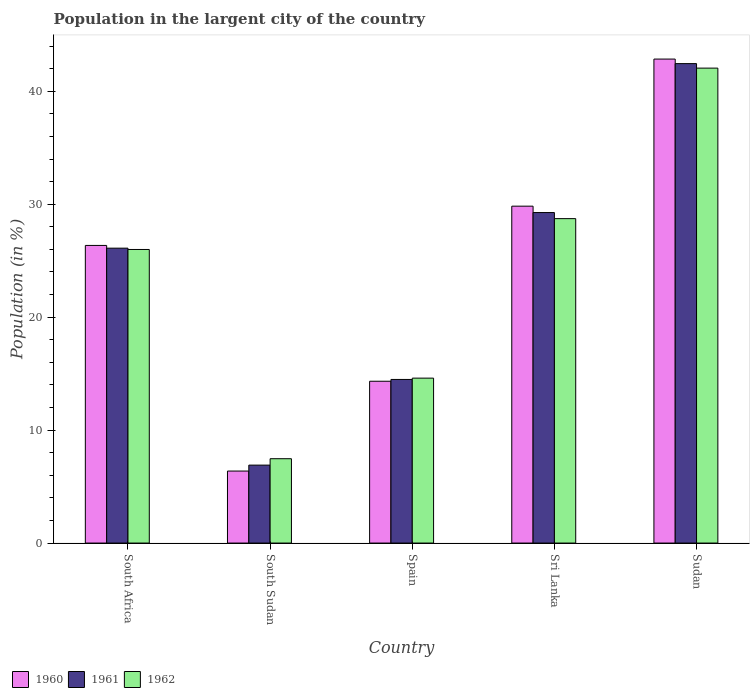How many groups of bars are there?
Give a very brief answer. 5. Are the number of bars per tick equal to the number of legend labels?
Provide a succinct answer. Yes. How many bars are there on the 1st tick from the left?
Your response must be concise. 3. What is the label of the 4th group of bars from the left?
Provide a short and direct response. Sri Lanka. In how many cases, is the number of bars for a given country not equal to the number of legend labels?
Give a very brief answer. 0. What is the percentage of population in the largent city in 1961 in Sri Lanka?
Your answer should be compact. 29.26. Across all countries, what is the maximum percentage of population in the largent city in 1962?
Offer a very short reply. 42.05. Across all countries, what is the minimum percentage of population in the largent city in 1962?
Keep it short and to the point. 7.47. In which country was the percentage of population in the largent city in 1960 maximum?
Give a very brief answer. Sudan. In which country was the percentage of population in the largent city in 1961 minimum?
Give a very brief answer. South Sudan. What is the total percentage of population in the largent city in 1960 in the graph?
Provide a succinct answer. 119.72. What is the difference between the percentage of population in the largent city in 1962 in South Sudan and that in Sri Lanka?
Your answer should be compact. -21.25. What is the difference between the percentage of population in the largent city in 1962 in Sri Lanka and the percentage of population in the largent city in 1960 in Spain?
Your answer should be compact. 14.39. What is the average percentage of population in the largent city in 1960 per country?
Your answer should be compact. 23.94. What is the difference between the percentage of population in the largent city of/in 1961 and percentage of population in the largent city of/in 1960 in South Africa?
Keep it short and to the point. -0.24. What is the ratio of the percentage of population in the largent city in 1960 in Spain to that in Sudan?
Make the answer very short. 0.33. What is the difference between the highest and the second highest percentage of population in the largent city in 1962?
Keep it short and to the point. -16.06. What is the difference between the highest and the lowest percentage of population in the largent city in 1961?
Make the answer very short. 35.55. In how many countries, is the percentage of population in the largent city in 1960 greater than the average percentage of population in the largent city in 1960 taken over all countries?
Your response must be concise. 3. Is the sum of the percentage of population in the largent city in 1960 in South Sudan and Sudan greater than the maximum percentage of population in the largent city in 1962 across all countries?
Offer a very short reply. Yes. Is it the case that in every country, the sum of the percentage of population in the largent city in 1960 and percentage of population in the largent city in 1962 is greater than the percentage of population in the largent city in 1961?
Ensure brevity in your answer.  Yes. What is the difference between two consecutive major ticks on the Y-axis?
Offer a terse response. 10. Does the graph contain any zero values?
Offer a very short reply. No. Where does the legend appear in the graph?
Keep it short and to the point. Bottom left. How many legend labels are there?
Provide a succinct answer. 3. How are the legend labels stacked?
Make the answer very short. Horizontal. What is the title of the graph?
Provide a succinct answer. Population in the largent city of the country. What is the label or title of the X-axis?
Your response must be concise. Country. What is the label or title of the Y-axis?
Offer a terse response. Population (in %). What is the Population (in %) in 1960 in South Africa?
Your answer should be very brief. 26.35. What is the Population (in %) of 1961 in South Africa?
Your answer should be very brief. 26.11. What is the Population (in %) of 1962 in South Africa?
Your answer should be very brief. 25.99. What is the Population (in %) of 1960 in South Sudan?
Your answer should be very brief. 6.37. What is the Population (in %) in 1961 in South Sudan?
Make the answer very short. 6.9. What is the Population (in %) in 1962 in South Sudan?
Your answer should be very brief. 7.47. What is the Population (in %) in 1960 in Spain?
Make the answer very short. 14.33. What is the Population (in %) of 1961 in Spain?
Offer a very short reply. 14.48. What is the Population (in %) in 1962 in Spain?
Offer a terse response. 14.6. What is the Population (in %) in 1960 in Sri Lanka?
Offer a terse response. 29.82. What is the Population (in %) of 1961 in Sri Lanka?
Make the answer very short. 29.26. What is the Population (in %) of 1962 in Sri Lanka?
Offer a terse response. 28.72. What is the Population (in %) in 1960 in Sudan?
Make the answer very short. 42.85. What is the Population (in %) in 1961 in Sudan?
Give a very brief answer. 42.45. What is the Population (in %) of 1962 in Sudan?
Your answer should be very brief. 42.05. Across all countries, what is the maximum Population (in %) of 1960?
Make the answer very short. 42.85. Across all countries, what is the maximum Population (in %) in 1961?
Provide a succinct answer. 42.45. Across all countries, what is the maximum Population (in %) in 1962?
Provide a succinct answer. 42.05. Across all countries, what is the minimum Population (in %) in 1960?
Your response must be concise. 6.37. Across all countries, what is the minimum Population (in %) in 1961?
Make the answer very short. 6.9. Across all countries, what is the minimum Population (in %) of 1962?
Your answer should be very brief. 7.47. What is the total Population (in %) of 1960 in the graph?
Your answer should be compact. 119.72. What is the total Population (in %) in 1961 in the graph?
Your answer should be compact. 119.19. What is the total Population (in %) of 1962 in the graph?
Your response must be concise. 118.82. What is the difference between the Population (in %) of 1960 in South Africa and that in South Sudan?
Provide a succinct answer. 19.97. What is the difference between the Population (in %) of 1961 in South Africa and that in South Sudan?
Your answer should be compact. 19.21. What is the difference between the Population (in %) in 1962 in South Africa and that in South Sudan?
Provide a succinct answer. 18.52. What is the difference between the Population (in %) in 1960 in South Africa and that in Spain?
Provide a succinct answer. 12.02. What is the difference between the Population (in %) of 1961 in South Africa and that in Spain?
Offer a very short reply. 11.62. What is the difference between the Population (in %) in 1962 in South Africa and that in Spain?
Provide a succinct answer. 11.39. What is the difference between the Population (in %) in 1960 in South Africa and that in Sri Lanka?
Ensure brevity in your answer.  -3.48. What is the difference between the Population (in %) of 1961 in South Africa and that in Sri Lanka?
Ensure brevity in your answer.  -3.15. What is the difference between the Population (in %) in 1962 in South Africa and that in Sri Lanka?
Your response must be concise. -2.73. What is the difference between the Population (in %) of 1960 in South Africa and that in Sudan?
Your answer should be compact. -16.5. What is the difference between the Population (in %) of 1961 in South Africa and that in Sudan?
Keep it short and to the point. -16.34. What is the difference between the Population (in %) in 1962 in South Africa and that in Sudan?
Your response must be concise. -16.06. What is the difference between the Population (in %) in 1960 in South Sudan and that in Spain?
Give a very brief answer. -7.95. What is the difference between the Population (in %) of 1961 in South Sudan and that in Spain?
Give a very brief answer. -7.58. What is the difference between the Population (in %) of 1962 in South Sudan and that in Spain?
Keep it short and to the point. -7.13. What is the difference between the Population (in %) in 1960 in South Sudan and that in Sri Lanka?
Offer a terse response. -23.45. What is the difference between the Population (in %) in 1961 in South Sudan and that in Sri Lanka?
Provide a short and direct response. -22.36. What is the difference between the Population (in %) in 1962 in South Sudan and that in Sri Lanka?
Keep it short and to the point. -21.25. What is the difference between the Population (in %) of 1960 in South Sudan and that in Sudan?
Your answer should be very brief. -36.47. What is the difference between the Population (in %) in 1961 in South Sudan and that in Sudan?
Ensure brevity in your answer.  -35.55. What is the difference between the Population (in %) in 1962 in South Sudan and that in Sudan?
Give a very brief answer. -34.58. What is the difference between the Population (in %) in 1960 in Spain and that in Sri Lanka?
Offer a terse response. -15.5. What is the difference between the Population (in %) of 1961 in Spain and that in Sri Lanka?
Make the answer very short. -14.78. What is the difference between the Population (in %) in 1962 in Spain and that in Sri Lanka?
Offer a terse response. -14.12. What is the difference between the Population (in %) of 1960 in Spain and that in Sudan?
Give a very brief answer. -28.52. What is the difference between the Population (in %) of 1961 in Spain and that in Sudan?
Offer a terse response. -27.96. What is the difference between the Population (in %) in 1962 in Spain and that in Sudan?
Provide a short and direct response. -27.45. What is the difference between the Population (in %) of 1960 in Sri Lanka and that in Sudan?
Provide a succinct answer. -13.02. What is the difference between the Population (in %) of 1961 in Sri Lanka and that in Sudan?
Make the answer very short. -13.19. What is the difference between the Population (in %) in 1962 in Sri Lanka and that in Sudan?
Make the answer very short. -13.33. What is the difference between the Population (in %) of 1960 in South Africa and the Population (in %) of 1961 in South Sudan?
Give a very brief answer. 19.45. What is the difference between the Population (in %) of 1960 in South Africa and the Population (in %) of 1962 in South Sudan?
Give a very brief answer. 18.88. What is the difference between the Population (in %) in 1961 in South Africa and the Population (in %) in 1962 in South Sudan?
Provide a short and direct response. 18.64. What is the difference between the Population (in %) in 1960 in South Africa and the Population (in %) in 1961 in Spain?
Your answer should be compact. 11.86. What is the difference between the Population (in %) in 1960 in South Africa and the Population (in %) in 1962 in Spain?
Give a very brief answer. 11.75. What is the difference between the Population (in %) of 1961 in South Africa and the Population (in %) of 1962 in Spain?
Offer a terse response. 11.51. What is the difference between the Population (in %) of 1960 in South Africa and the Population (in %) of 1961 in Sri Lanka?
Give a very brief answer. -2.91. What is the difference between the Population (in %) of 1960 in South Africa and the Population (in %) of 1962 in Sri Lanka?
Offer a very short reply. -2.37. What is the difference between the Population (in %) in 1961 in South Africa and the Population (in %) in 1962 in Sri Lanka?
Offer a very short reply. -2.61. What is the difference between the Population (in %) in 1960 in South Africa and the Population (in %) in 1961 in Sudan?
Keep it short and to the point. -16.1. What is the difference between the Population (in %) in 1960 in South Africa and the Population (in %) in 1962 in Sudan?
Your answer should be compact. -15.7. What is the difference between the Population (in %) of 1961 in South Africa and the Population (in %) of 1962 in Sudan?
Offer a very short reply. -15.94. What is the difference between the Population (in %) in 1960 in South Sudan and the Population (in %) in 1961 in Spain?
Your answer should be compact. -8.11. What is the difference between the Population (in %) of 1960 in South Sudan and the Population (in %) of 1962 in Spain?
Ensure brevity in your answer.  -8.23. What is the difference between the Population (in %) in 1961 in South Sudan and the Population (in %) in 1962 in Spain?
Provide a succinct answer. -7.7. What is the difference between the Population (in %) of 1960 in South Sudan and the Population (in %) of 1961 in Sri Lanka?
Make the answer very short. -22.89. What is the difference between the Population (in %) of 1960 in South Sudan and the Population (in %) of 1962 in Sri Lanka?
Your response must be concise. -22.35. What is the difference between the Population (in %) in 1961 in South Sudan and the Population (in %) in 1962 in Sri Lanka?
Ensure brevity in your answer.  -21.82. What is the difference between the Population (in %) in 1960 in South Sudan and the Population (in %) in 1961 in Sudan?
Offer a very short reply. -36.07. What is the difference between the Population (in %) of 1960 in South Sudan and the Population (in %) of 1962 in Sudan?
Provide a short and direct response. -35.67. What is the difference between the Population (in %) in 1961 in South Sudan and the Population (in %) in 1962 in Sudan?
Give a very brief answer. -35.15. What is the difference between the Population (in %) of 1960 in Spain and the Population (in %) of 1961 in Sri Lanka?
Ensure brevity in your answer.  -14.93. What is the difference between the Population (in %) in 1960 in Spain and the Population (in %) in 1962 in Sri Lanka?
Offer a terse response. -14.39. What is the difference between the Population (in %) in 1961 in Spain and the Population (in %) in 1962 in Sri Lanka?
Offer a very short reply. -14.24. What is the difference between the Population (in %) of 1960 in Spain and the Population (in %) of 1961 in Sudan?
Make the answer very short. -28.12. What is the difference between the Population (in %) of 1960 in Spain and the Population (in %) of 1962 in Sudan?
Offer a very short reply. -27.72. What is the difference between the Population (in %) of 1961 in Spain and the Population (in %) of 1962 in Sudan?
Make the answer very short. -27.56. What is the difference between the Population (in %) of 1960 in Sri Lanka and the Population (in %) of 1961 in Sudan?
Provide a succinct answer. -12.62. What is the difference between the Population (in %) of 1960 in Sri Lanka and the Population (in %) of 1962 in Sudan?
Offer a terse response. -12.22. What is the difference between the Population (in %) in 1961 in Sri Lanka and the Population (in %) in 1962 in Sudan?
Offer a very short reply. -12.79. What is the average Population (in %) of 1960 per country?
Keep it short and to the point. 23.94. What is the average Population (in %) of 1961 per country?
Keep it short and to the point. 23.84. What is the average Population (in %) of 1962 per country?
Offer a very short reply. 23.76. What is the difference between the Population (in %) of 1960 and Population (in %) of 1961 in South Africa?
Keep it short and to the point. 0.24. What is the difference between the Population (in %) in 1960 and Population (in %) in 1962 in South Africa?
Ensure brevity in your answer.  0.36. What is the difference between the Population (in %) in 1961 and Population (in %) in 1962 in South Africa?
Offer a very short reply. 0.12. What is the difference between the Population (in %) of 1960 and Population (in %) of 1961 in South Sudan?
Make the answer very short. -0.53. What is the difference between the Population (in %) in 1960 and Population (in %) in 1962 in South Sudan?
Your answer should be compact. -1.09. What is the difference between the Population (in %) of 1961 and Population (in %) of 1962 in South Sudan?
Provide a succinct answer. -0.57. What is the difference between the Population (in %) of 1960 and Population (in %) of 1961 in Spain?
Your answer should be compact. -0.16. What is the difference between the Population (in %) in 1960 and Population (in %) in 1962 in Spain?
Your answer should be compact. -0.27. What is the difference between the Population (in %) in 1961 and Population (in %) in 1962 in Spain?
Your response must be concise. -0.12. What is the difference between the Population (in %) of 1960 and Population (in %) of 1961 in Sri Lanka?
Your response must be concise. 0.57. What is the difference between the Population (in %) in 1960 and Population (in %) in 1962 in Sri Lanka?
Offer a very short reply. 1.1. What is the difference between the Population (in %) of 1961 and Population (in %) of 1962 in Sri Lanka?
Provide a short and direct response. 0.54. What is the difference between the Population (in %) in 1960 and Population (in %) in 1961 in Sudan?
Your answer should be very brief. 0.4. What is the difference between the Population (in %) of 1960 and Population (in %) of 1962 in Sudan?
Your response must be concise. 0.8. What is the difference between the Population (in %) of 1961 and Population (in %) of 1962 in Sudan?
Provide a short and direct response. 0.4. What is the ratio of the Population (in %) in 1960 in South Africa to that in South Sudan?
Ensure brevity in your answer.  4.13. What is the ratio of the Population (in %) in 1961 in South Africa to that in South Sudan?
Provide a succinct answer. 3.78. What is the ratio of the Population (in %) in 1962 in South Africa to that in South Sudan?
Provide a succinct answer. 3.48. What is the ratio of the Population (in %) of 1960 in South Africa to that in Spain?
Provide a succinct answer. 1.84. What is the ratio of the Population (in %) of 1961 in South Africa to that in Spain?
Ensure brevity in your answer.  1.8. What is the ratio of the Population (in %) in 1962 in South Africa to that in Spain?
Offer a terse response. 1.78. What is the ratio of the Population (in %) in 1960 in South Africa to that in Sri Lanka?
Your answer should be very brief. 0.88. What is the ratio of the Population (in %) of 1961 in South Africa to that in Sri Lanka?
Your response must be concise. 0.89. What is the ratio of the Population (in %) of 1962 in South Africa to that in Sri Lanka?
Offer a very short reply. 0.9. What is the ratio of the Population (in %) in 1960 in South Africa to that in Sudan?
Your answer should be compact. 0.61. What is the ratio of the Population (in %) of 1961 in South Africa to that in Sudan?
Your answer should be very brief. 0.62. What is the ratio of the Population (in %) in 1962 in South Africa to that in Sudan?
Keep it short and to the point. 0.62. What is the ratio of the Population (in %) in 1960 in South Sudan to that in Spain?
Your response must be concise. 0.44. What is the ratio of the Population (in %) of 1961 in South Sudan to that in Spain?
Your answer should be very brief. 0.48. What is the ratio of the Population (in %) of 1962 in South Sudan to that in Spain?
Ensure brevity in your answer.  0.51. What is the ratio of the Population (in %) of 1960 in South Sudan to that in Sri Lanka?
Give a very brief answer. 0.21. What is the ratio of the Population (in %) of 1961 in South Sudan to that in Sri Lanka?
Give a very brief answer. 0.24. What is the ratio of the Population (in %) in 1962 in South Sudan to that in Sri Lanka?
Offer a very short reply. 0.26. What is the ratio of the Population (in %) in 1960 in South Sudan to that in Sudan?
Provide a short and direct response. 0.15. What is the ratio of the Population (in %) in 1961 in South Sudan to that in Sudan?
Your response must be concise. 0.16. What is the ratio of the Population (in %) in 1962 in South Sudan to that in Sudan?
Offer a terse response. 0.18. What is the ratio of the Population (in %) of 1960 in Spain to that in Sri Lanka?
Offer a terse response. 0.48. What is the ratio of the Population (in %) in 1961 in Spain to that in Sri Lanka?
Give a very brief answer. 0.49. What is the ratio of the Population (in %) of 1962 in Spain to that in Sri Lanka?
Your answer should be compact. 0.51. What is the ratio of the Population (in %) in 1960 in Spain to that in Sudan?
Your answer should be compact. 0.33. What is the ratio of the Population (in %) in 1961 in Spain to that in Sudan?
Provide a succinct answer. 0.34. What is the ratio of the Population (in %) of 1962 in Spain to that in Sudan?
Your answer should be very brief. 0.35. What is the ratio of the Population (in %) of 1960 in Sri Lanka to that in Sudan?
Keep it short and to the point. 0.7. What is the ratio of the Population (in %) of 1961 in Sri Lanka to that in Sudan?
Your answer should be compact. 0.69. What is the ratio of the Population (in %) of 1962 in Sri Lanka to that in Sudan?
Your answer should be compact. 0.68. What is the difference between the highest and the second highest Population (in %) of 1960?
Keep it short and to the point. 13.02. What is the difference between the highest and the second highest Population (in %) in 1961?
Your response must be concise. 13.19. What is the difference between the highest and the second highest Population (in %) of 1962?
Offer a very short reply. 13.33. What is the difference between the highest and the lowest Population (in %) in 1960?
Ensure brevity in your answer.  36.47. What is the difference between the highest and the lowest Population (in %) in 1961?
Provide a succinct answer. 35.55. What is the difference between the highest and the lowest Population (in %) of 1962?
Ensure brevity in your answer.  34.58. 